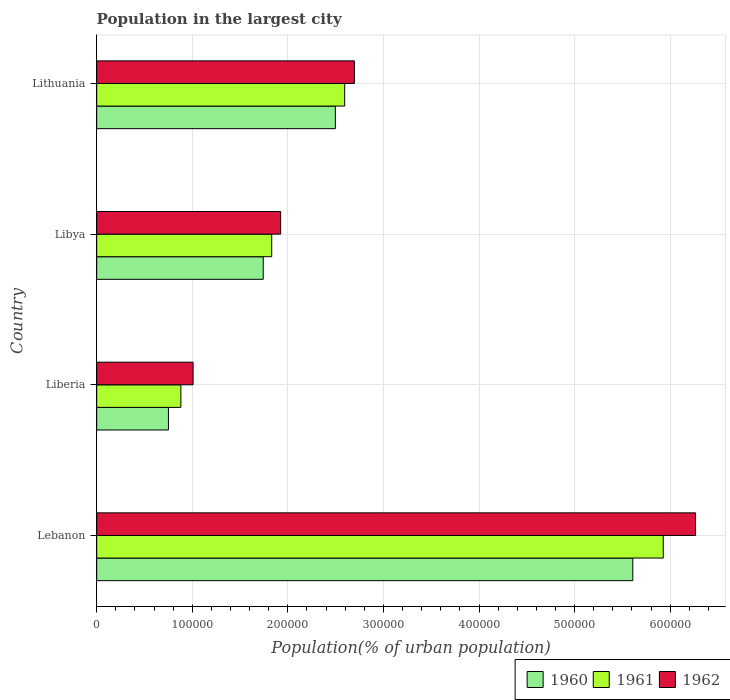How many different coloured bars are there?
Your answer should be compact. 3. How many groups of bars are there?
Your answer should be very brief. 4. How many bars are there on the 3rd tick from the top?
Your answer should be very brief. 3. What is the label of the 1st group of bars from the top?
Your response must be concise. Lithuania. In how many cases, is the number of bars for a given country not equal to the number of legend labels?
Keep it short and to the point. 0. What is the population in the largest city in 1962 in Lithuania?
Your response must be concise. 2.70e+05. Across all countries, what is the maximum population in the largest city in 1960?
Make the answer very short. 5.61e+05. Across all countries, what is the minimum population in the largest city in 1960?
Offer a terse response. 7.51e+04. In which country was the population in the largest city in 1960 maximum?
Offer a terse response. Lebanon. In which country was the population in the largest city in 1960 minimum?
Provide a short and direct response. Liberia. What is the total population in the largest city in 1960 in the graph?
Make the answer very short. 1.06e+06. What is the difference between the population in the largest city in 1960 in Lebanon and that in Liberia?
Make the answer very short. 4.86e+05. What is the difference between the population in the largest city in 1962 in Liberia and the population in the largest city in 1961 in Lebanon?
Offer a very short reply. -4.92e+05. What is the average population in the largest city in 1960 per country?
Offer a terse response. 2.65e+05. What is the difference between the population in the largest city in 1962 and population in the largest city in 1961 in Lithuania?
Ensure brevity in your answer.  1.02e+04. In how many countries, is the population in the largest city in 1960 greater than 60000 %?
Give a very brief answer. 4. What is the ratio of the population in the largest city in 1960 in Liberia to that in Lithuania?
Provide a short and direct response. 0.3. Is the population in the largest city in 1961 in Liberia less than that in Libya?
Provide a succinct answer. Yes. What is the difference between the highest and the second highest population in the largest city in 1962?
Your answer should be compact. 3.57e+05. What is the difference between the highest and the lowest population in the largest city in 1962?
Ensure brevity in your answer.  5.26e+05. What does the 1st bar from the top in Liberia represents?
Your response must be concise. 1962. What does the 2nd bar from the bottom in Lithuania represents?
Keep it short and to the point. 1961. Is it the case that in every country, the sum of the population in the largest city in 1962 and population in the largest city in 1961 is greater than the population in the largest city in 1960?
Make the answer very short. Yes. How many bars are there?
Your answer should be compact. 12. Are all the bars in the graph horizontal?
Your response must be concise. Yes. How many countries are there in the graph?
Your answer should be very brief. 4. What is the difference between two consecutive major ticks on the X-axis?
Your answer should be compact. 1.00e+05. How are the legend labels stacked?
Offer a very short reply. Horizontal. What is the title of the graph?
Offer a very short reply. Population in the largest city. What is the label or title of the X-axis?
Offer a terse response. Population(% of urban population). What is the Population(% of urban population) of 1960 in Lebanon?
Provide a succinct answer. 5.61e+05. What is the Population(% of urban population) of 1961 in Lebanon?
Offer a very short reply. 5.93e+05. What is the Population(% of urban population) of 1962 in Lebanon?
Your answer should be compact. 6.27e+05. What is the Population(% of urban population) in 1960 in Liberia?
Offer a terse response. 7.51e+04. What is the Population(% of urban population) of 1961 in Liberia?
Ensure brevity in your answer.  8.81e+04. What is the Population(% of urban population) of 1962 in Liberia?
Offer a very short reply. 1.01e+05. What is the Population(% of urban population) in 1960 in Libya?
Your answer should be very brief. 1.74e+05. What is the Population(% of urban population) of 1961 in Libya?
Offer a terse response. 1.83e+05. What is the Population(% of urban population) of 1962 in Libya?
Provide a succinct answer. 1.92e+05. What is the Population(% of urban population) in 1960 in Lithuania?
Provide a short and direct response. 2.50e+05. What is the Population(% of urban population) in 1961 in Lithuania?
Offer a terse response. 2.59e+05. What is the Population(% of urban population) of 1962 in Lithuania?
Ensure brevity in your answer.  2.70e+05. Across all countries, what is the maximum Population(% of urban population) of 1960?
Ensure brevity in your answer.  5.61e+05. Across all countries, what is the maximum Population(% of urban population) in 1961?
Make the answer very short. 5.93e+05. Across all countries, what is the maximum Population(% of urban population) in 1962?
Make the answer very short. 6.27e+05. Across all countries, what is the minimum Population(% of urban population) in 1960?
Your answer should be very brief. 7.51e+04. Across all countries, what is the minimum Population(% of urban population) of 1961?
Your answer should be very brief. 8.81e+04. Across all countries, what is the minimum Population(% of urban population) of 1962?
Offer a terse response. 1.01e+05. What is the total Population(% of urban population) of 1960 in the graph?
Offer a terse response. 1.06e+06. What is the total Population(% of urban population) in 1961 in the graph?
Offer a very short reply. 1.12e+06. What is the total Population(% of urban population) of 1962 in the graph?
Your response must be concise. 1.19e+06. What is the difference between the Population(% of urban population) of 1960 in Lebanon and that in Liberia?
Your response must be concise. 4.86e+05. What is the difference between the Population(% of urban population) of 1961 in Lebanon and that in Liberia?
Ensure brevity in your answer.  5.05e+05. What is the difference between the Population(% of urban population) in 1962 in Lebanon and that in Liberia?
Offer a very short reply. 5.26e+05. What is the difference between the Population(% of urban population) in 1960 in Lebanon and that in Libya?
Provide a short and direct response. 3.87e+05. What is the difference between the Population(% of urban population) of 1961 in Lebanon and that in Libya?
Keep it short and to the point. 4.10e+05. What is the difference between the Population(% of urban population) of 1962 in Lebanon and that in Libya?
Give a very brief answer. 4.34e+05. What is the difference between the Population(% of urban population) of 1960 in Lebanon and that in Lithuania?
Give a very brief answer. 3.11e+05. What is the difference between the Population(% of urban population) in 1961 in Lebanon and that in Lithuania?
Your response must be concise. 3.33e+05. What is the difference between the Population(% of urban population) in 1962 in Lebanon and that in Lithuania?
Offer a terse response. 3.57e+05. What is the difference between the Population(% of urban population) in 1960 in Liberia and that in Libya?
Make the answer very short. -9.92e+04. What is the difference between the Population(% of urban population) of 1961 in Liberia and that in Libya?
Provide a succinct answer. -9.51e+04. What is the difference between the Population(% of urban population) of 1962 in Liberia and that in Libya?
Your answer should be very brief. -9.16e+04. What is the difference between the Population(% of urban population) in 1960 in Liberia and that in Lithuania?
Make the answer very short. -1.75e+05. What is the difference between the Population(% of urban population) in 1961 in Liberia and that in Lithuania?
Keep it short and to the point. -1.71e+05. What is the difference between the Population(% of urban population) in 1962 in Liberia and that in Lithuania?
Keep it short and to the point. -1.69e+05. What is the difference between the Population(% of urban population) of 1960 in Libya and that in Lithuania?
Offer a terse response. -7.55e+04. What is the difference between the Population(% of urban population) in 1961 in Libya and that in Lithuania?
Keep it short and to the point. -7.63e+04. What is the difference between the Population(% of urban population) of 1962 in Libya and that in Lithuania?
Offer a very short reply. -7.72e+04. What is the difference between the Population(% of urban population) of 1960 in Lebanon and the Population(% of urban population) of 1961 in Liberia?
Keep it short and to the point. 4.73e+05. What is the difference between the Population(% of urban population) of 1960 in Lebanon and the Population(% of urban population) of 1962 in Liberia?
Provide a short and direct response. 4.60e+05. What is the difference between the Population(% of urban population) of 1961 in Lebanon and the Population(% of urban population) of 1962 in Liberia?
Your answer should be very brief. 4.92e+05. What is the difference between the Population(% of urban population) of 1960 in Lebanon and the Population(% of urban population) of 1961 in Libya?
Offer a terse response. 3.78e+05. What is the difference between the Population(% of urban population) in 1960 in Lebanon and the Population(% of urban population) in 1962 in Libya?
Offer a very short reply. 3.68e+05. What is the difference between the Population(% of urban population) in 1961 in Lebanon and the Population(% of urban population) in 1962 in Libya?
Ensure brevity in your answer.  4.00e+05. What is the difference between the Population(% of urban population) of 1960 in Lebanon and the Population(% of urban population) of 1961 in Lithuania?
Your answer should be compact. 3.01e+05. What is the difference between the Population(% of urban population) in 1960 in Lebanon and the Population(% of urban population) in 1962 in Lithuania?
Ensure brevity in your answer.  2.91e+05. What is the difference between the Population(% of urban population) of 1961 in Lebanon and the Population(% of urban population) of 1962 in Lithuania?
Provide a succinct answer. 3.23e+05. What is the difference between the Population(% of urban population) in 1960 in Liberia and the Population(% of urban population) in 1961 in Libya?
Your answer should be very brief. -1.08e+05. What is the difference between the Population(% of urban population) in 1960 in Liberia and the Population(% of urban population) in 1962 in Libya?
Ensure brevity in your answer.  -1.17e+05. What is the difference between the Population(% of urban population) in 1961 in Liberia and the Population(% of urban population) in 1962 in Libya?
Provide a short and direct response. -1.04e+05. What is the difference between the Population(% of urban population) in 1960 in Liberia and the Population(% of urban population) in 1961 in Lithuania?
Provide a succinct answer. -1.84e+05. What is the difference between the Population(% of urban population) of 1960 in Liberia and the Population(% of urban population) of 1962 in Lithuania?
Offer a terse response. -1.95e+05. What is the difference between the Population(% of urban population) in 1961 in Liberia and the Population(% of urban population) in 1962 in Lithuania?
Make the answer very short. -1.82e+05. What is the difference between the Population(% of urban population) in 1960 in Libya and the Population(% of urban population) in 1961 in Lithuania?
Your response must be concise. -8.52e+04. What is the difference between the Population(% of urban population) in 1960 in Libya and the Population(% of urban population) in 1962 in Lithuania?
Your response must be concise. -9.54e+04. What is the difference between the Population(% of urban population) of 1961 in Libya and the Population(% of urban population) of 1962 in Lithuania?
Your answer should be very brief. -8.65e+04. What is the average Population(% of urban population) in 1960 per country?
Make the answer very short. 2.65e+05. What is the average Population(% of urban population) of 1961 per country?
Offer a very short reply. 2.81e+05. What is the average Population(% of urban population) in 1962 per country?
Your response must be concise. 2.97e+05. What is the difference between the Population(% of urban population) in 1960 and Population(% of urban population) in 1961 in Lebanon?
Offer a terse response. -3.19e+04. What is the difference between the Population(% of urban population) in 1960 and Population(% of urban population) in 1962 in Lebanon?
Offer a terse response. -6.56e+04. What is the difference between the Population(% of urban population) in 1961 and Population(% of urban population) in 1962 in Lebanon?
Make the answer very short. -3.38e+04. What is the difference between the Population(% of urban population) in 1960 and Population(% of urban population) in 1961 in Liberia?
Keep it short and to the point. -1.30e+04. What is the difference between the Population(% of urban population) in 1960 and Population(% of urban population) in 1962 in Liberia?
Ensure brevity in your answer.  -2.58e+04. What is the difference between the Population(% of urban population) of 1961 and Population(% of urban population) of 1962 in Liberia?
Offer a very short reply. -1.28e+04. What is the difference between the Population(% of urban population) in 1960 and Population(% of urban population) in 1961 in Libya?
Your answer should be very brief. -8884. What is the difference between the Population(% of urban population) of 1960 and Population(% of urban population) of 1962 in Libya?
Offer a terse response. -1.82e+04. What is the difference between the Population(% of urban population) in 1961 and Population(% of urban population) in 1962 in Libya?
Ensure brevity in your answer.  -9351. What is the difference between the Population(% of urban population) of 1960 and Population(% of urban population) of 1961 in Lithuania?
Keep it short and to the point. -9768. What is the difference between the Population(% of urban population) of 1960 and Population(% of urban population) of 1962 in Lithuania?
Provide a short and direct response. -1.99e+04. What is the difference between the Population(% of urban population) of 1961 and Population(% of urban population) of 1962 in Lithuania?
Keep it short and to the point. -1.02e+04. What is the ratio of the Population(% of urban population) of 1960 in Lebanon to that in Liberia?
Ensure brevity in your answer.  7.47. What is the ratio of the Population(% of urban population) of 1961 in Lebanon to that in Liberia?
Your answer should be very brief. 6.73. What is the ratio of the Population(% of urban population) in 1962 in Lebanon to that in Liberia?
Give a very brief answer. 6.21. What is the ratio of the Population(% of urban population) of 1960 in Lebanon to that in Libya?
Your answer should be very brief. 3.22. What is the ratio of the Population(% of urban population) of 1961 in Lebanon to that in Libya?
Offer a terse response. 3.24. What is the ratio of the Population(% of urban population) of 1962 in Lebanon to that in Libya?
Give a very brief answer. 3.26. What is the ratio of the Population(% of urban population) in 1960 in Lebanon to that in Lithuania?
Ensure brevity in your answer.  2.25. What is the ratio of the Population(% of urban population) of 1961 in Lebanon to that in Lithuania?
Keep it short and to the point. 2.28. What is the ratio of the Population(% of urban population) in 1962 in Lebanon to that in Lithuania?
Give a very brief answer. 2.32. What is the ratio of the Population(% of urban population) of 1960 in Liberia to that in Libya?
Give a very brief answer. 0.43. What is the ratio of the Population(% of urban population) of 1961 in Liberia to that in Libya?
Provide a short and direct response. 0.48. What is the ratio of the Population(% of urban population) of 1962 in Liberia to that in Libya?
Offer a terse response. 0.52. What is the ratio of the Population(% of urban population) of 1960 in Liberia to that in Lithuania?
Your response must be concise. 0.3. What is the ratio of the Population(% of urban population) in 1961 in Liberia to that in Lithuania?
Keep it short and to the point. 0.34. What is the ratio of the Population(% of urban population) in 1962 in Liberia to that in Lithuania?
Give a very brief answer. 0.37. What is the ratio of the Population(% of urban population) of 1960 in Libya to that in Lithuania?
Keep it short and to the point. 0.7. What is the ratio of the Population(% of urban population) of 1961 in Libya to that in Lithuania?
Make the answer very short. 0.71. What is the ratio of the Population(% of urban population) in 1962 in Libya to that in Lithuania?
Offer a terse response. 0.71. What is the difference between the highest and the second highest Population(% of urban population) of 1960?
Give a very brief answer. 3.11e+05. What is the difference between the highest and the second highest Population(% of urban population) in 1961?
Offer a terse response. 3.33e+05. What is the difference between the highest and the second highest Population(% of urban population) in 1962?
Offer a very short reply. 3.57e+05. What is the difference between the highest and the lowest Population(% of urban population) in 1960?
Give a very brief answer. 4.86e+05. What is the difference between the highest and the lowest Population(% of urban population) of 1961?
Your answer should be very brief. 5.05e+05. What is the difference between the highest and the lowest Population(% of urban population) in 1962?
Provide a short and direct response. 5.26e+05. 